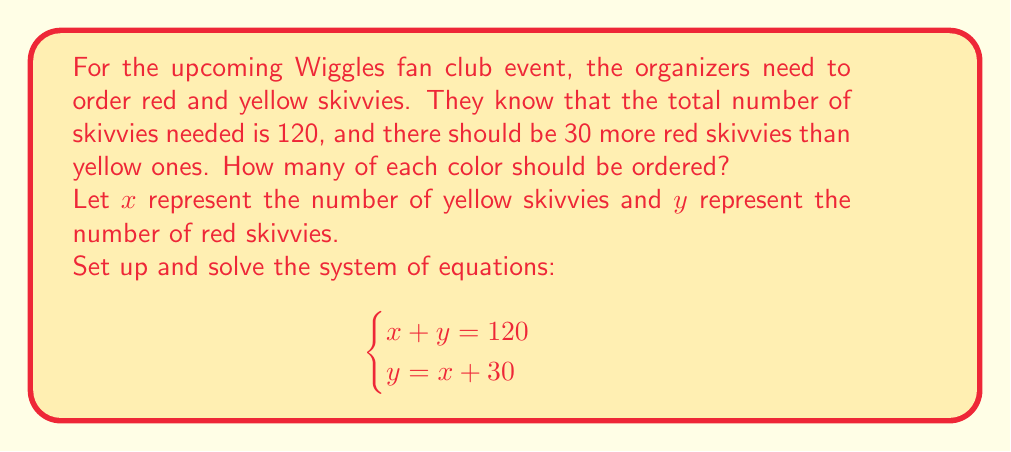Could you help me with this problem? Let's solve this system of equations step by step:

1. We have two equations:
   $$\begin{cases}
   x + y = 120 \quad \text{(Equation 1)} \\
   y = x + 30 \quad \text{(Equation 2)}
   \end{cases}$$

2. Substitute Equation 2 into Equation 1:
   $$x + (x + 30) = 120$$

3. Simplify:
   $$2x + 30 = 120$$

4. Subtract 30 from both sides:
   $$2x = 90$$

5. Divide both sides by 2:
   $$x = 45$$

6. Now that we know $x$, we can find $y$ using Equation 2:
   $$y = x + 30 = 45 + 30 = 75$$

Therefore, 45 yellow skivvies and 75 red skivvies should be ordered.
Answer: 45 yellow, 75 red 